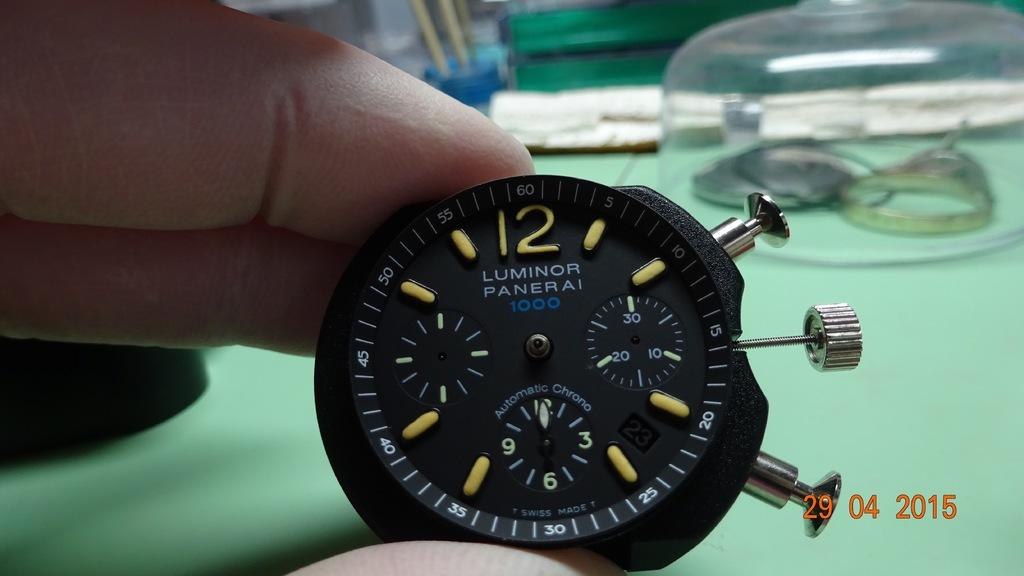<image>
Provide a brief description of the given image. Watch face for the Luminor Panerai 1000 model. 